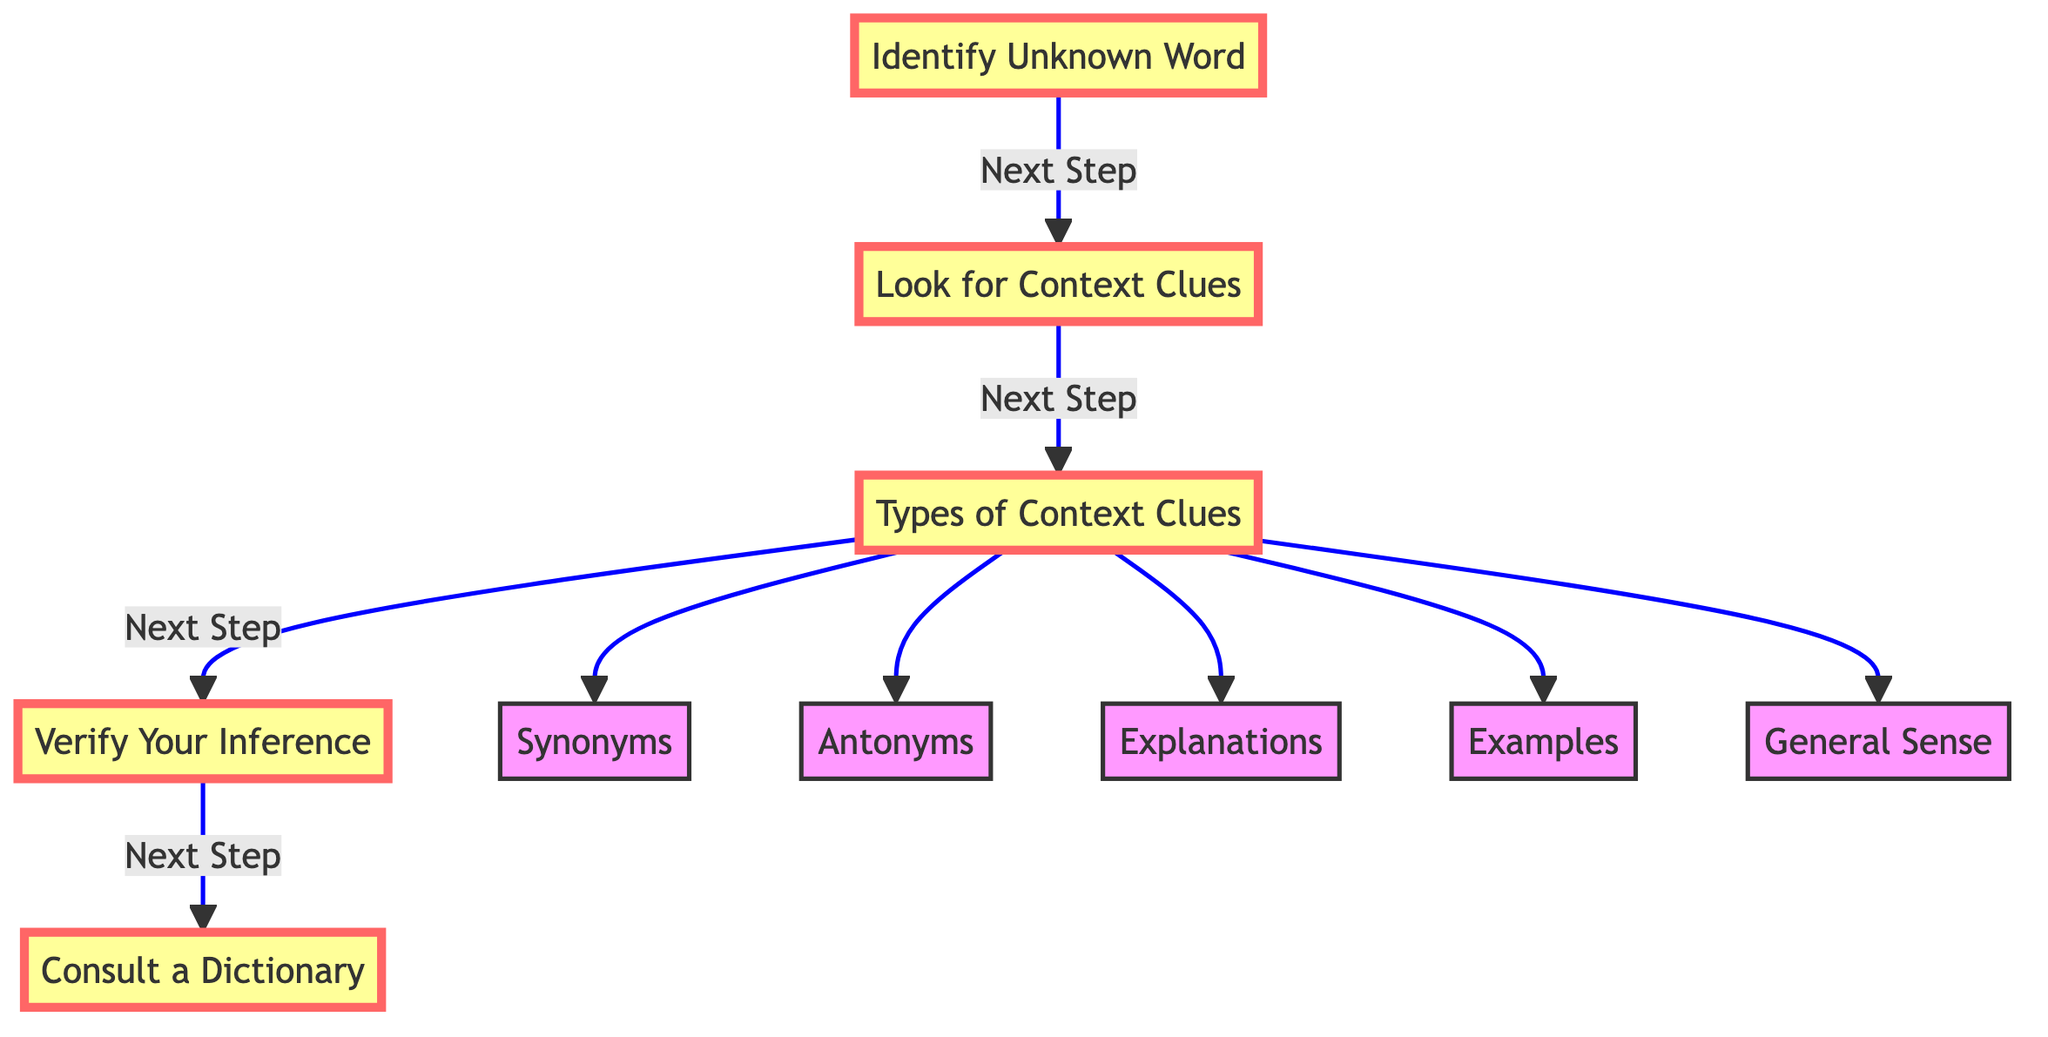What is the first step in the flow chart? The flow chart starts with the node "Identify Unknown Word," which is the first action to take when applying context clues.
Answer: Identify Unknown Word How many types of context clues are there? There are five types of context clues listed in the diagram: Synonyms, Antonyms, Explanations, Examples, and General Sense.
Answer: Five What is the purpose of the 'Verify Your Inference' step? The step 'Verify Your Inference' aims to check if the inferred meaning of the word makes sense when it's replaced in the sentence.
Answer: Check inferred meaning Which node follows 'Look for Context Clues'? After 'Look for Context Clues,' the next step is 'Types of Context Clues,' indicating that it elaborates on various types of context clues one should consider.
Answer: Types of Context Clues What is the last step in the flow chart? The final step in the flow chart is 'Consult a Dictionary,' which is about confirming the meaning of the word using a dictionary for better understanding.
Answer: Consult a Dictionary How are 'Synonyms' and 'Antonyms' related in the context of the diagram? Both 'Synonyms' and 'Antonyms' are categorized under 'Types of Context Clues,' suggesting they are both ways to deduce the meaning of the unknown word.
Answer: Both are types of context clues Which step includes examples that give hints about the unknown word? The step 'Examples' under 'Types of Context Clues' specifically refers to providing instances that help clarify the meaning of the unknown word.
Answer: Examples If a user reaches 'Consult a Dictionary,' what have they likely done before? A user would have likely gone through the earlier steps of identifying the word, looking for context clues, and verifying their inference before reaching this step.
Answer: Prior steps How does the diagram emphasize the flow of actions? The diagram uses arrows to connect each node to the next, showing a clear sequence of steps that guide the reader from starting to final action.
Answer: Arrows connect nodes 